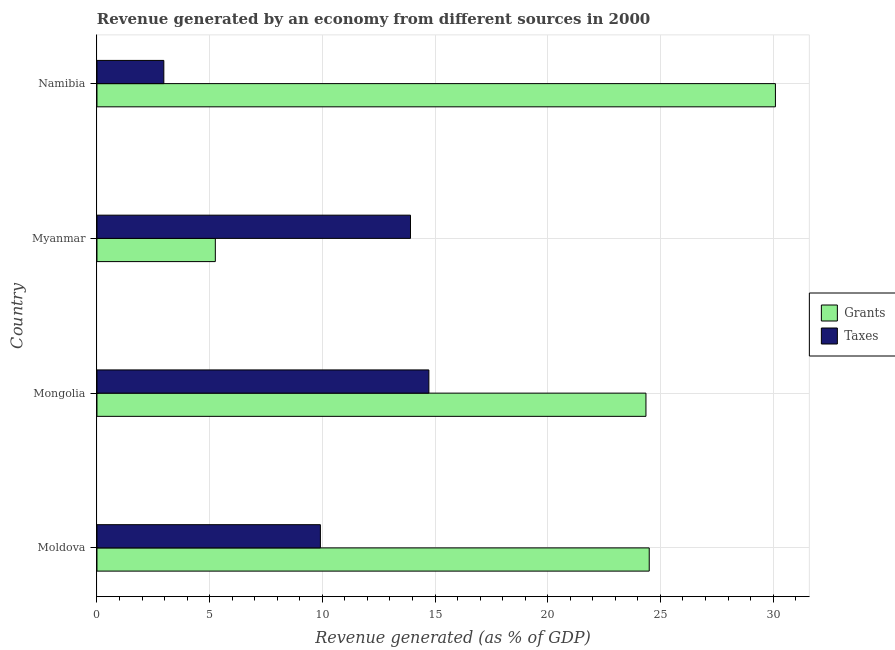How many different coloured bars are there?
Give a very brief answer. 2. How many bars are there on the 3rd tick from the top?
Provide a short and direct response. 2. How many bars are there on the 2nd tick from the bottom?
Offer a terse response. 2. What is the label of the 4th group of bars from the top?
Provide a succinct answer. Moldova. In how many cases, is the number of bars for a given country not equal to the number of legend labels?
Your answer should be compact. 0. What is the revenue generated by taxes in Mongolia?
Keep it short and to the point. 14.73. Across all countries, what is the maximum revenue generated by taxes?
Make the answer very short. 14.73. Across all countries, what is the minimum revenue generated by grants?
Your response must be concise. 5.25. In which country was the revenue generated by taxes maximum?
Your answer should be compact. Mongolia. In which country was the revenue generated by grants minimum?
Provide a short and direct response. Myanmar. What is the total revenue generated by taxes in the graph?
Offer a terse response. 41.52. What is the difference between the revenue generated by grants in Moldova and that in Namibia?
Keep it short and to the point. -5.6. What is the difference between the revenue generated by taxes in Moldova and the revenue generated by grants in Myanmar?
Provide a succinct answer. 4.66. What is the average revenue generated by taxes per country?
Your response must be concise. 10.38. What is the difference between the revenue generated by grants and revenue generated by taxes in Mongolia?
Ensure brevity in your answer.  9.63. What is the ratio of the revenue generated by grants in Myanmar to that in Namibia?
Ensure brevity in your answer.  0.17. Is the difference between the revenue generated by grants in Moldova and Namibia greater than the difference between the revenue generated by taxes in Moldova and Namibia?
Keep it short and to the point. No. What is the difference between the highest and the second highest revenue generated by grants?
Your answer should be very brief. 5.6. What is the difference between the highest and the lowest revenue generated by taxes?
Offer a terse response. 11.76. Is the sum of the revenue generated by grants in Mongolia and Namibia greater than the maximum revenue generated by taxes across all countries?
Keep it short and to the point. Yes. What does the 2nd bar from the top in Myanmar represents?
Your answer should be compact. Grants. What does the 2nd bar from the bottom in Myanmar represents?
Offer a very short reply. Taxes. What is the difference between two consecutive major ticks on the X-axis?
Your answer should be compact. 5. Where does the legend appear in the graph?
Keep it short and to the point. Center right. How are the legend labels stacked?
Your response must be concise. Vertical. What is the title of the graph?
Your answer should be very brief. Revenue generated by an economy from different sources in 2000. Does "constant 2005 US$" appear as one of the legend labels in the graph?
Give a very brief answer. No. What is the label or title of the X-axis?
Provide a short and direct response. Revenue generated (as % of GDP). What is the Revenue generated (as % of GDP) in Grants in Moldova?
Your response must be concise. 24.5. What is the Revenue generated (as % of GDP) of Taxes in Moldova?
Your answer should be very brief. 9.91. What is the Revenue generated (as % of GDP) of Grants in Mongolia?
Offer a terse response. 24.36. What is the Revenue generated (as % of GDP) of Taxes in Mongolia?
Give a very brief answer. 14.73. What is the Revenue generated (as % of GDP) of Grants in Myanmar?
Provide a succinct answer. 5.25. What is the Revenue generated (as % of GDP) of Taxes in Myanmar?
Offer a very short reply. 13.91. What is the Revenue generated (as % of GDP) of Grants in Namibia?
Give a very brief answer. 30.1. What is the Revenue generated (as % of GDP) of Taxes in Namibia?
Your response must be concise. 2.97. Across all countries, what is the maximum Revenue generated (as % of GDP) in Grants?
Offer a terse response. 30.1. Across all countries, what is the maximum Revenue generated (as % of GDP) in Taxes?
Keep it short and to the point. 14.73. Across all countries, what is the minimum Revenue generated (as % of GDP) in Grants?
Provide a succinct answer. 5.25. Across all countries, what is the minimum Revenue generated (as % of GDP) of Taxes?
Keep it short and to the point. 2.97. What is the total Revenue generated (as % of GDP) of Grants in the graph?
Your answer should be very brief. 84.21. What is the total Revenue generated (as % of GDP) in Taxes in the graph?
Keep it short and to the point. 41.52. What is the difference between the Revenue generated (as % of GDP) of Grants in Moldova and that in Mongolia?
Provide a succinct answer. 0.15. What is the difference between the Revenue generated (as % of GDP) in Taxes in Moldova and that in Mongolia?
Give a very brief answer. -4.81. What is the difference between the Revenue generated (as % of GDP) of Grants in Moldova and that in Myanmar?
Provide a succinct answer. 19.25. What is the difference between the Revenue generated (as % of GDP) of Taxes in Moldova and that in Myanmar?
Your answer should be compact. -4. What is the difference between the Revenue generated (as % of GDP) in Grants in Moldova and that in Namibia?
Your response must be concise. -5.6. What is the difference between the Revenue generated (as % of GDP) in Taxes in Moldova and that in Namibia?
Your answer should be compact. 6.95. What is the difference between the Revenue generated (as % of GDP) of Grants in Mongolia and that in Myanmar?
Offer a terse response. 19.11. What is the difference between the Revenue generated (as % of GDP) of Taxes in Mongolia and that in Myanmar?
Your response must be concise. 0.82. What is the difference between the Revenue generated (as % of GDP) of Grants in Mongolia and that in Namibia?
Provide a short and direct response. -5.74. What is the difference between the Revenue generated (as % of GDP) in Taxes in Mongolia and that in Namibia?
Ensure brevity in your answer.  11.76. What is the difference between the Revenue generated (as % of GDP) in Grants in Myanmar and that in Namibia?
Make the answer very short. -24.85. What is the difference between the Revenue generated (as % of GDP) in Taxes in Myanmar and that in Namibia?
Offer a terse response. 10.94. What is the difference between the Revenue generated (as % of GDP) of Grants in Moldova and the Revenue generated (as % of GDP) of Taxes in Mongolia?
Your answer should be compact. 9.78. What is the difference between the Revenue generated (as % of GDP) in Grants in Moldova and the Revenue generated (as % of GDP) in Taxes in Myanmar?
Your answer should be very brief. 10.59. What is the difference between the Revenue generated (as % of GDP) in Grants in Moldova and the Revenue generated (as % of GDP) in Taxes in Namibia?
Offer a very short reply. 21.54. What is the difference between the Revenue generated (as % of GDP) in Grants in Mongolia and the Revenue generated (as % of GDP) in Taxes in Myanmar?
Offer a very short reply. 10.45. What is the difference between the Revenue generated (as % of GDP) in Grants in Mongolia and the Revenue generated (as % of GDP) in Taxes in Namibia?
Offer a very short reply. 21.39. What is the difference between the Revenue generated (as % of GDP) in Grants in Myanmar and the Revenue generated (as % of GDP) in Taxes in Namibia?
Ensure brevity in your answer.  2.28. What is the average Revenue generated (as % of GDP) in Grants per country?
Ensure brevity in your answer.  21.05. What is the average Revenue generated (as % of GDP) in Taxes per country?
Ensure brevity in your answer.  10.38. What is the difference between the Revenue generated (as % of GDP) in Grants and Revenue generated (as % of GDP) in Taxes in Moldova?
Your answer should be very brief. 14.59. What is the difference between the Revenue generated (as % of GDP) in Grants and Revenue generated (as % of GDP) in Taxes in Mongolia?
Ensure brevity in your answer.  9.63. What is the difference between the Revenue generated (as % of GDP) of Grants and Revenue generated (as % of GDP) of Taxes in Myanmar?
Give a very brief answer. -8.66. What is the difference between the Revenue generated (as % of GDP) in Grants and Revenue generated (as % of GDP) in Taxes in Namibia?
Keep it short and to the point. 27.13. What is the ratio of the Revenue generated (as % of GDP) in Taxes in Moldova to that in Mongolia?
Provide a short and direct response. 0.67. What is the ratio of the Revenue generated (as % of GDP) in Grants in Moldova to that in Myanmar?
Your response must be concise. 4.67. What is the ratio of the Revenue generated (as % of GDP) in Taxes in Moldova to that in Myanmar?
Provide a short and direct response. 0.71. What is the ratio of the Revenue generated (as % of GDP) in Grants in Moldova to that in Namibia?
Your answer should be compact. 0.81. What is the ratio of the Revenue generated (as % of GDP) of Taxes in Moldova to that in Namibia?
Your response must be concise. 3.34. What is the ratio of the Revenue generated (as % of GDP) of Grants in Mongolia to that in Myanmar?
Your answer should be very brief. 4.64. What is the ratio of the Revenue generated (as % of GDP) of Taxes in Mongolia to that in Myanmar?
Offer a very short reply. 1.06. What is the ratio of the Revenue generated (as % of GDP) in Grants in Mongolia to that in Namibia?
Offer a very short reply. 0.81. What is the ratio of the Revenue generated (as % of GDP) in Taxes in Mongolia to that in Namibia?
Provide a short and direct response. 4.96. What is the ratio of the Revenue generated (as % of GDP) in Grants in Myanmar to that in Namibia?
Your answer should be compact. 0.17. What is the ratio of the Revenue generated (as % of GDP) in Taxes in Myanmar to that in Namibia?
Offer a terse response. 4.69. What is the difference between the highest and the second highest Revenue generated (as % of GDP) in Grants?
Your response must be concise. 5.6. What is the difference between the highest and the second highest Revenue generated (as % of GDP) in Taxes?
Offer a very short reply. 0.82. What is the difference between the highest and the lowest Revenue generated (as % of GDP) in Grants?
Offer a very short reply. 24.85. What is the difference between the highest and the lowest Revenue generated (as % of GDP) in Taxes?
Your response must be concise. 11.76. 